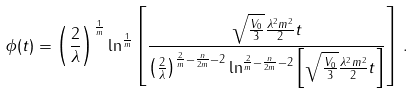<formula> <loc_0><loc_0><loc_500><loc_500>\phi ( t ) = \left ( \frac { 2 } { \lambda } \right ) ^ { \frac { 1 } { m } } \ln ^ { \frac { 1 } { m } } \left [ \frac { \sqrt { \frac { V _ { 0 } } { 3 } } \frac { \lambda ^ { 2 } m ^ { 2 } } { 2 } t } { { \left ( \frac { 2 } { \lambda } \right ) } ^ { \frac { 2 } { m } - \frac { n } { 2 m } - 2 } \ln ^ { \frac { 2 } { m } - \frac { n } { 2 m } - 2 } \left [ \sqrt { \frac { V _ { 0 } } { 3 } } \frac { \lambda ^ { 2 } m ^ { 2 } } { 2 } t \right ] } \right ] \, .</formula> 